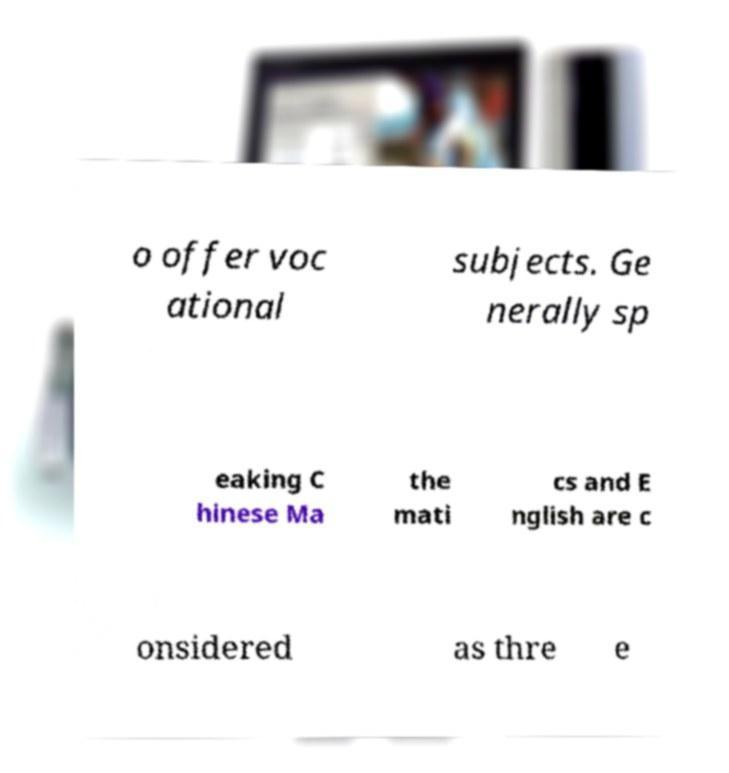Can you accurately transcribe the text from the provided image for me? o offer voc ational subjects. Ge nerally sp eaking C hinese Ma the mati cs and E nglish are c onsidered as thre e 